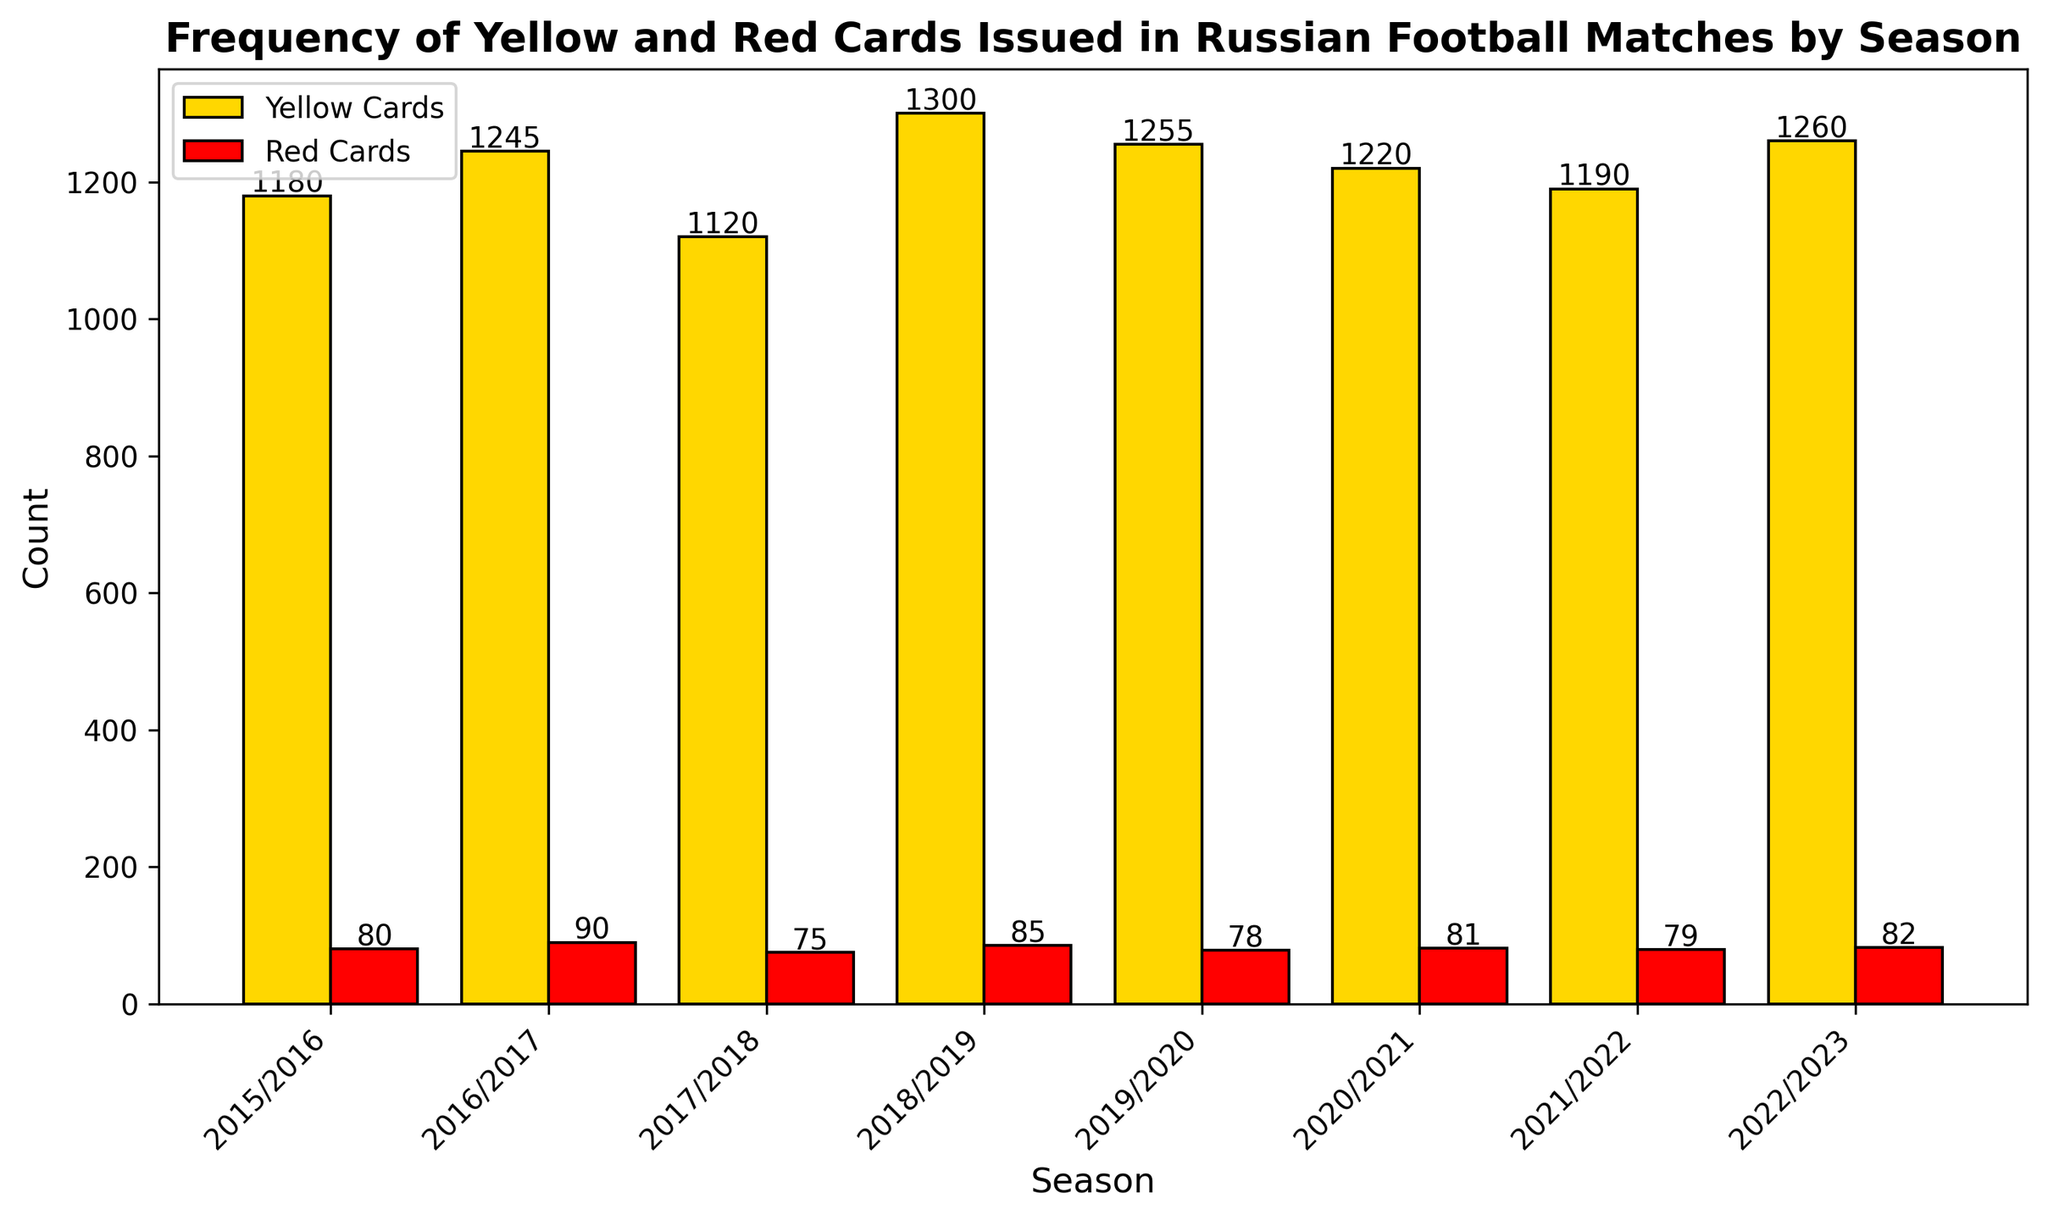Which season had the highest number of yellow cards issued? The bars representing yellow cards are shown in gold. By comparing their heights, we can see that the bar for the 2018/2019 season is the tallest, indicating this season has the highest number of yellow cards.
Answer: 2018/2019 Between which two consecutive seasons did the red card count increase the most? By observing the red bars, we compare the heights for consecutive seasons. The largest increase is from the 2016/2017 season (90 red cards) to the 2018/2019 season (85 red cards increased from 75). Therefore, the greatest increase in red cards occurs between 2017/2018 and 2018/2019 seasons.
Answer: 2017/2018 and 2018/2019 Which season had the least number of red cards issued? The bars representing red cards are shown in red. By scanning for the shortest red bar, we can identify the 2017/2018 season as the one with the least red cards.
Answer: 2017/2018 What is the average number of yellow cards issued per season? To find the average, sum the number of yellow cards for all seasons and divide by the number of seasons. The sum is 1180 + 1245 + 1120 + 1300 + 1255 + 1220 + 1190 + 1260 = 9770. There are 8 seasons, so the average is 9770 / 8 = 1221.25.
Answer: 1221.25 Did any season have an equal number of yellow and red cards? By comparing individual bars in pairs, none of the gold (yellow cards) and red (red cards) bars are at the same height. Hence, no season has an equal number of yellow and red cards.
Answer: No How many more yellow cards were issued compared to red cards in the 2016/2017 season? For 2016/2017, there are 1245 yellow cards and 90 red cards. To find the difference, subtract the red cards from the yellow cards: 1245 - 90 = 1155.
Answer: 1155 What is the total number of red cards issued over the given seasons? Add up the red cards from all seasons: 80 + 90 + 75 + 85 + 78 + 81 + 79 + 82 = 650.
Answer: 650 Which seasons had more than 85 red cards issued? By inspecting the red bars and their corresponding values, we can see that only the 2016/2017 season, with 90 red cards, had more than 85 red cards issued.
Answer: 2016/2017 Which season had a higher total card count (yellow plus red) than the average total card count across all seasons? First, calculate the total card count for each season and then find the sum and average across all seasons. Total card count per season: (1180+80), (1245+90), (1120+75), (1300+85), (1255+78), (1220+81), (1190+79), (1260+82) = 1260, 1335, 1195, 1385, 1333, 1301, 1269, 1342 respectively. Sum is 10420, so average is 10420 / 8 = 1302.5. The 2018/2019 season and 2022/2023 seasons have higher total card counts than 1302.5.
Answer: 2018/2019, 2022/2023 By how much did the number of yellow cards decrease from the highest season to the lowest season? The highest yellow card season (1300 in 2018/2019) and the lowest yellow card season (1120 in 2017/2018) yield a difference of 1300 - 1120 = 180.
Answer: 180 